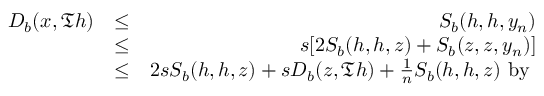<formula> <loc_0><loc_0><loc_500><loc_500>\begin{array} { r l r } { D _ { b } ( x , \mathfrak { T } h ) } & { \leq } & { S _ { b } ( h , h , y _ { n } ) } \\ & { \leq } & { s [ 2 S _ { b } ( h , h , z ) + S _ { b } ( z , z , y _ { n } ) ] } \\ & { \leq } & { 2 s S _ { b } ( h , h , z ) + s D _ { b } ( z , \mathfrak { T } h ) + \frac { 1 } { n } S _ { b } ( h , h , z ) b y } \end{array}</formula> 